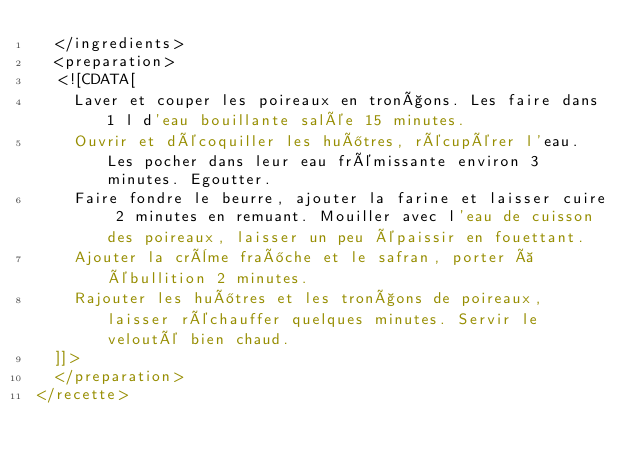Convert code to text. <code><loc_0><loc_0><loc_500><loc_500><_XML_>  </ingredients>
  <preparation>
  <![CDATA[
    Laver et couper les poireaux en tronçons. Les faire dans 1 l d'eau bouillante salée 15 minutes.
    Ouvrir et décoquiller les huîtres, récupérer l'eau. Les pocher dans leur eau frémissante environ 3 minutes. Egoutter.
    Faire fondre le beurre, ajouter la farine et laisser cuire 2 minutes en remuant. Mouiller avec l'eau de cuisson des poireaux, laisser un peu épaissir en fouettant.
    Ajouter la crème fraîche et le safran, porter à ébullition 2 minutes.
    Rajouter les huîtres et les tronçons de poireaux, laisser réchauffer quelques minutes. Servir le velouté bien chaud.
  ]]>
  </preparation>
</recette>
</code> 